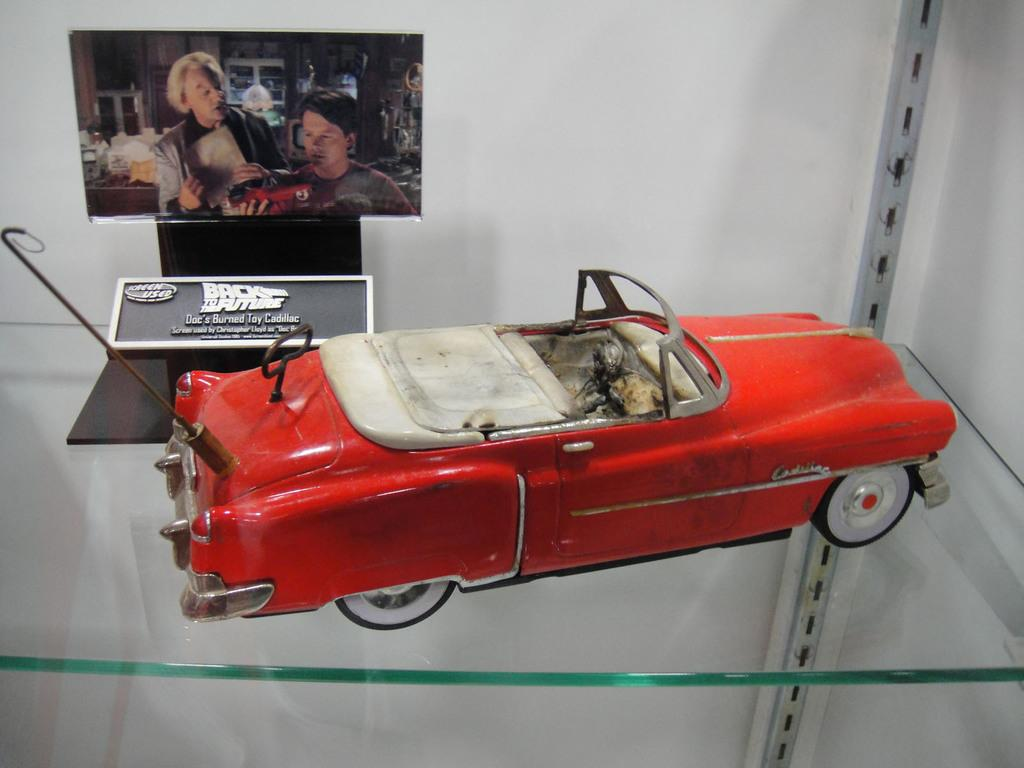What is the main object in the image? There is a toy car in the image. Where is the toy car located? The toy car is on a glass desk. What color is the toy car? The toy car is red in color. What can be seen on the left side of the image? There is a photograph on the left side of the image. What is visible in the background of the image? There is a wall in the background of the image. What type of scarf is draped over the toy car in the image? There is no scarf present in the image; the toy car is on a glass desk and is red in color. 